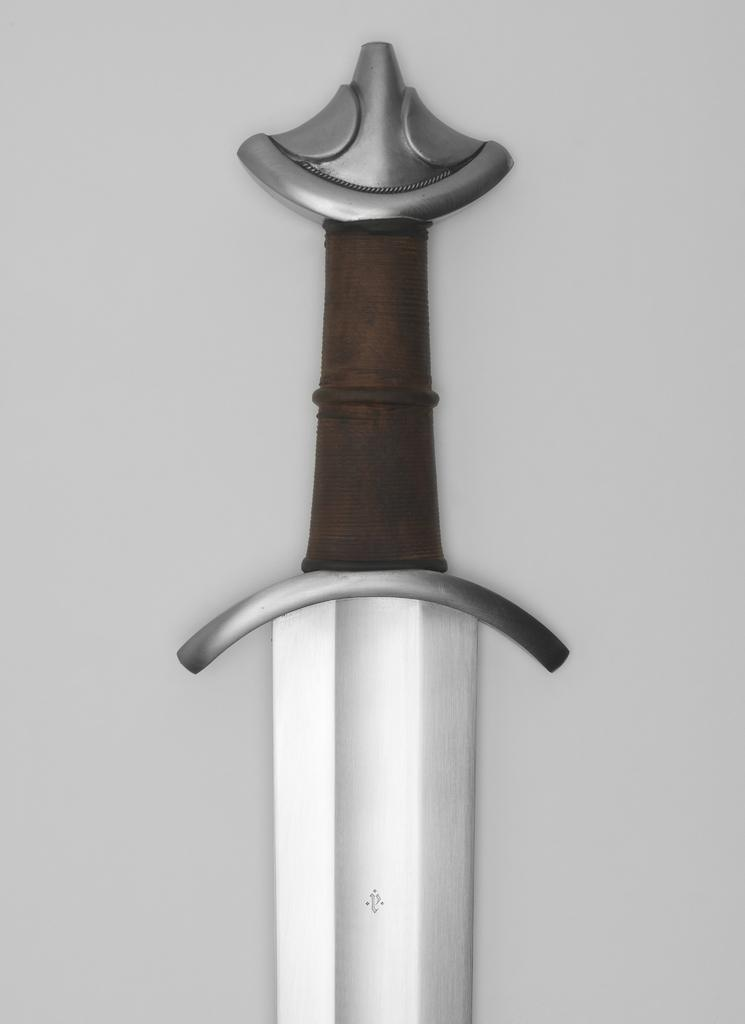What is the main object in the center of the image? There is a sword in the center of the image. What can be seen in the background of the image? There is a wall visible in the background of the image. Where is the dog located in the image? There is no dog present in the image. What type of station is visible in the image? There is no station present in the image. 